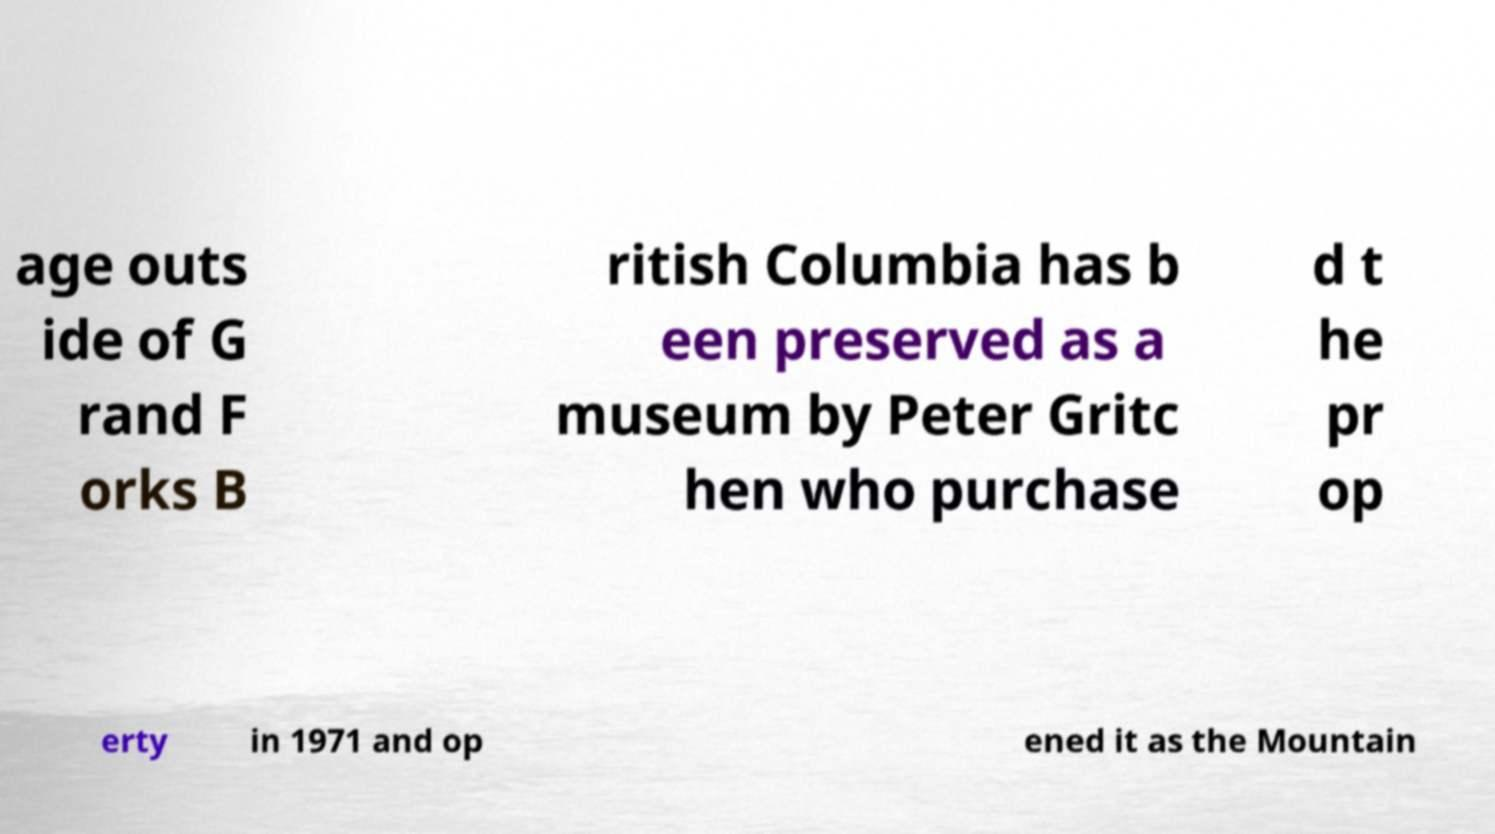Could you assist in decoding the text presented in this image and type it out clearly? age outs ide of G rand F orks B ritish Columbia has b een preserved as a museum by Peter Gritc hen who purchase d t he pr op erty in 1971 and op ened it as the Mountain 